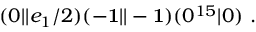Convert formula to latex. <formula><loc_0><loc_0><loc_500><loc_500>( 0 | | e _ { 1 } / 2 ) ( - { 1 } | | - { 1 } ) ( 0 ^ { 1 5 } | 0 ) .</formula> 